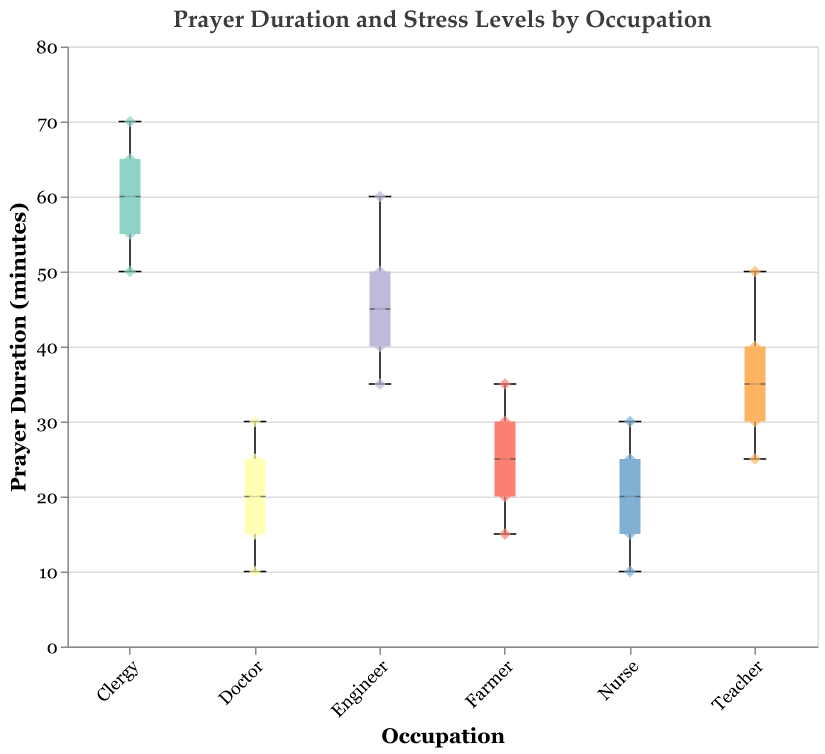What's the median prayer duration for teachers? The box plot shows the central tendency for each occupational group's prayer durations. For teachers, the median is represented by a horizontal line inside the box, which is at 35 minutes.
Answer: 35 minutes Which occupation has the widest range of prayer durations? The range can be determined by the distance between the minimum and maximum points in the box plot. Engineers show the widest range from 35 to 60 minutes, which is a range of 25 minutes.
Answer: Engineers Which occupation has the lowest stress levels associated with the longest prayer durations? By looking at both the box plot and scatter points, clergy have the longest prayer durations with median around 60 minutes and stress levels mostly between 1 and 3.
Answer: Clergy What's the interquartile range (IQR) for farmers? The IQR is the range between the first quartile (Q1) and the third quartile (Q3). For farmers, Q1 is at 20 minutes and Q3 is at 30 minutes, so IQR is 30 - 20 = 10 minutes.
Answer: 10 minutes How do teachers' prayer durations compare with those of nurses? The median prayer duration for teachers is 35 minutes, while for nurses it is around 20 minutes. Teachers generally pray for a longer duration compared to nurses, as seen by the higher median and overall greater range.
Answer: Teachers pray longer In which occupations do we see the largest overlap in prayer durations? Teachers and engineers show the largest overlap, with both groups having prayer durations within the range of approximately 25 to 50 minutes.
Answer: Teachers and engineers Which group shows the highest stress levels with the shortest prayer durations? By inspecting the scatter points, doctors exhibit high stress levels, primarily around 7-9, with shorter prayer durations ranging from 10 to 30 minutes.
Answer: Doctors Which occupational group has the most clustered prayer durations around a specific value? Nurses have prayer durations clustered around 20-25 minutes, as indicated by the box plot with a tight interquartile range and several scatter points near these values.
Answer: Nurses What is the average prayer duration across all groups? Calculate the prayer durations for every occupation, sum them up, and divide by the number of data points (30). The sum is 820 minutes, thus the average is 820/30 = approximately 27.3 minutes.
Answer: 27.3 minutes How does prayer duration seem to affect stress levels among different occupations? By observing both the box plot and scatter points, durations higher than 40 minutes are often associated with stress levels below 5, particularly for clergy and engineers. Shorter prayer durations (like those of nurses and doctors) seem to correlate with higher stress levels of 6 and above.
Answer: Longer prayer durations correlate with lower stress levels 